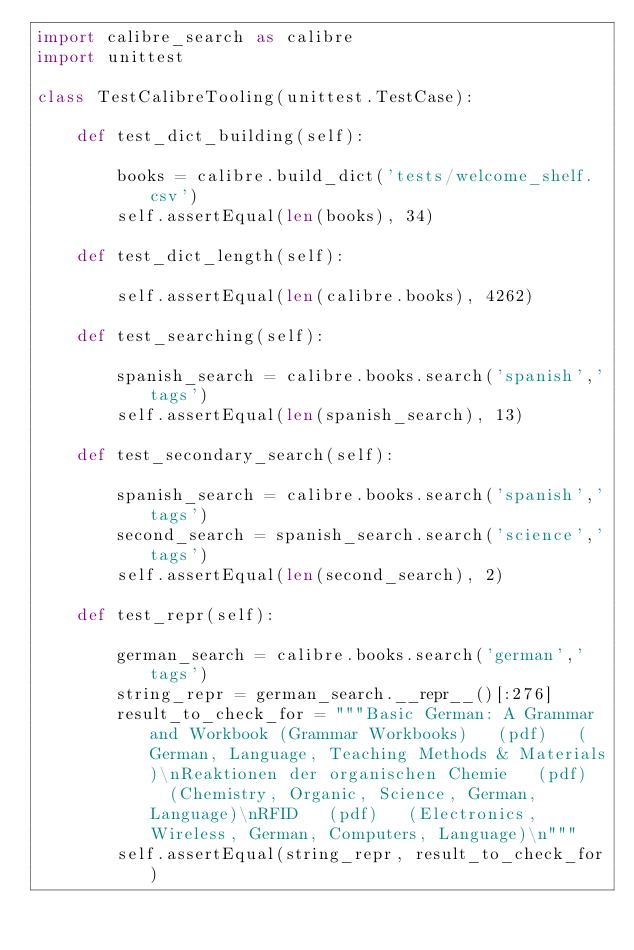<code> <loc_0><loc_0><loc_500><loc_500><_Python_>import calibre_search as calibre
import unittest

class TestCalibreTooling(unittest.TestCase):

    def test_dict_building(self):
        
        books = calibre.build_dict('tests/welcome_shelf.csv')                                                                                                
        self.assertEqual(len(books), 34)

    def test_dict_length(self):
        
        self.assertEqual(len(calibre.books), 4262)

    def test_searching(self):

        spanish_search = calibre.books.search('spanish','tags')                                                                                    
        self.assertEqual(len(spanish_search), 13)

    def test_secondary_search(self):

        spanish_search = calibre.books.search('spanish','tags')                                                                                    
        second_search = spanish_search.search('science','tags')
        self.assertEqual(len(second_search), 2)

    def test_repr(self):

        german_search = calibre.books.search('german','tags')
        string_repr = german_search.__repr__()[:276]
        result_to_check_for = """Basic German: A Grammar and Workbook (Grammar Workbooks)   (pdf)   (German, Language, Teaching Methods & Materials)\nReaktionen der organischen Chemie   (pdf)   (Chemistry, Organic, Science, German, Language)\nRFID   (pdf)   (Electronics, Wireless, German, Computers, Language)\n"""
        self.assertEqual(string_repr, result_to_check_for)</code> 